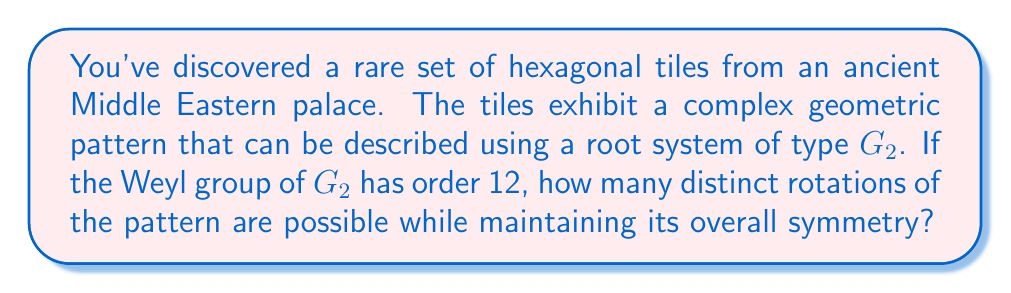Can you answer this question? To solve this problem, we need to understand the relationship between the root system $G_2$, its Weyl group, and the symmetries of the hexagonal tiling pattern.

1) The root system $G_2$ is associated with the exceptional Lie algebra $\mathfrak{g}_2$. It has 12 roots in total, arranged in a hexagonal pattern in the plane.

2) The Weyl group of $G_2$, denoted $W(G_2)$, is the group of symmetries of this root system. We're given that $|W(G_2)| = 12$.

3) The Weyl group of $G_2$ is isomorphic to the dihedral group $D_6$, which is the symmetry group of a regular hexagon. This makes sense given the hexagonal nature of the tiles.

4) The elements of $D_6$ consist of:
   - The identity transformation
   - 5 rotations (by 60°, 120°, 180°, 240°, and 300°)
   - 6 reflections (across the 3 diagonals and 3 bisectors of the hexagon)

5) We're asked specifically about rotations. In the Weyl group, these correspond to the rotational elements of $D_6$.

6) Counting the rotations:
   - The identity (rotation by 0°)
   - Rotation by 60°
   - Rotation by 120°
   - Rotation by 180°
   - Rotation by 240°
   - Rotation by 300°

Therefore, there are 6 distinct rotations (including the identity) that preserve the symmetry of the pattern.

[asy]
import geometry;

size(200);
real r = 5;
for(int i=0; i<6; ++i) {
  draw(rotate(60*i)*(r,0)--(r*cos(pi/3),r*sin(pi/3)));
}
for(int i=0; i<6; ++i) {
  dot(rotate(60*i)*(r,0));
}
label("$G_2$ root system", (0,-6));
[/asy]
Answer: 6 distinct rotations 